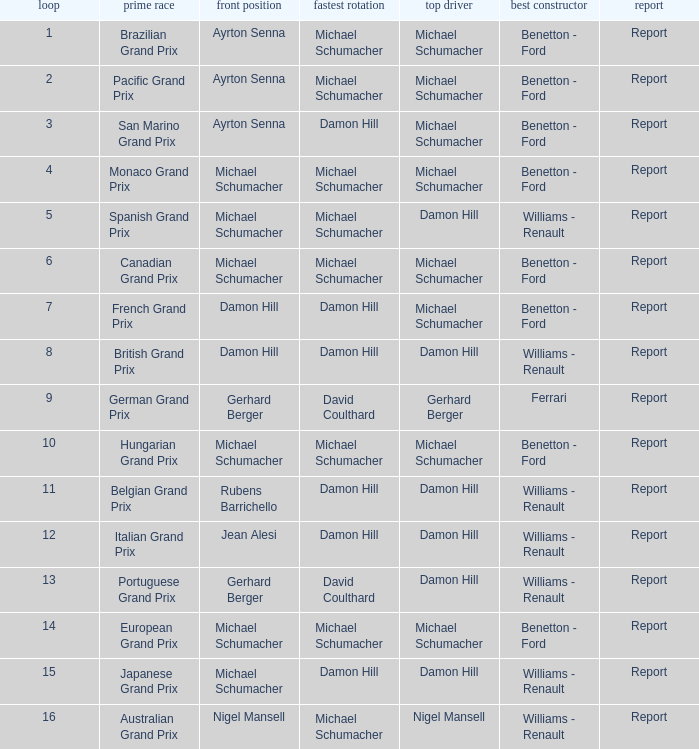Name the fastest lap for the brazilian grand prix Michael Schumacher. 